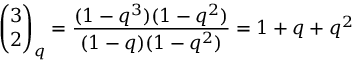Convert formula to latex. <formula><loc_0><loc_0><loc_500><loc_500>{ \binom { 3 } { 2 } } _ { q } = { \frac { ( 1 - q ^ { 3 } ) ( 1 - q ^ { 2 } ) } { ( 1 - q ) ( 1 - q ^ { 2 } ) } } = 1 + q + q ^ { 2 }</formula> 